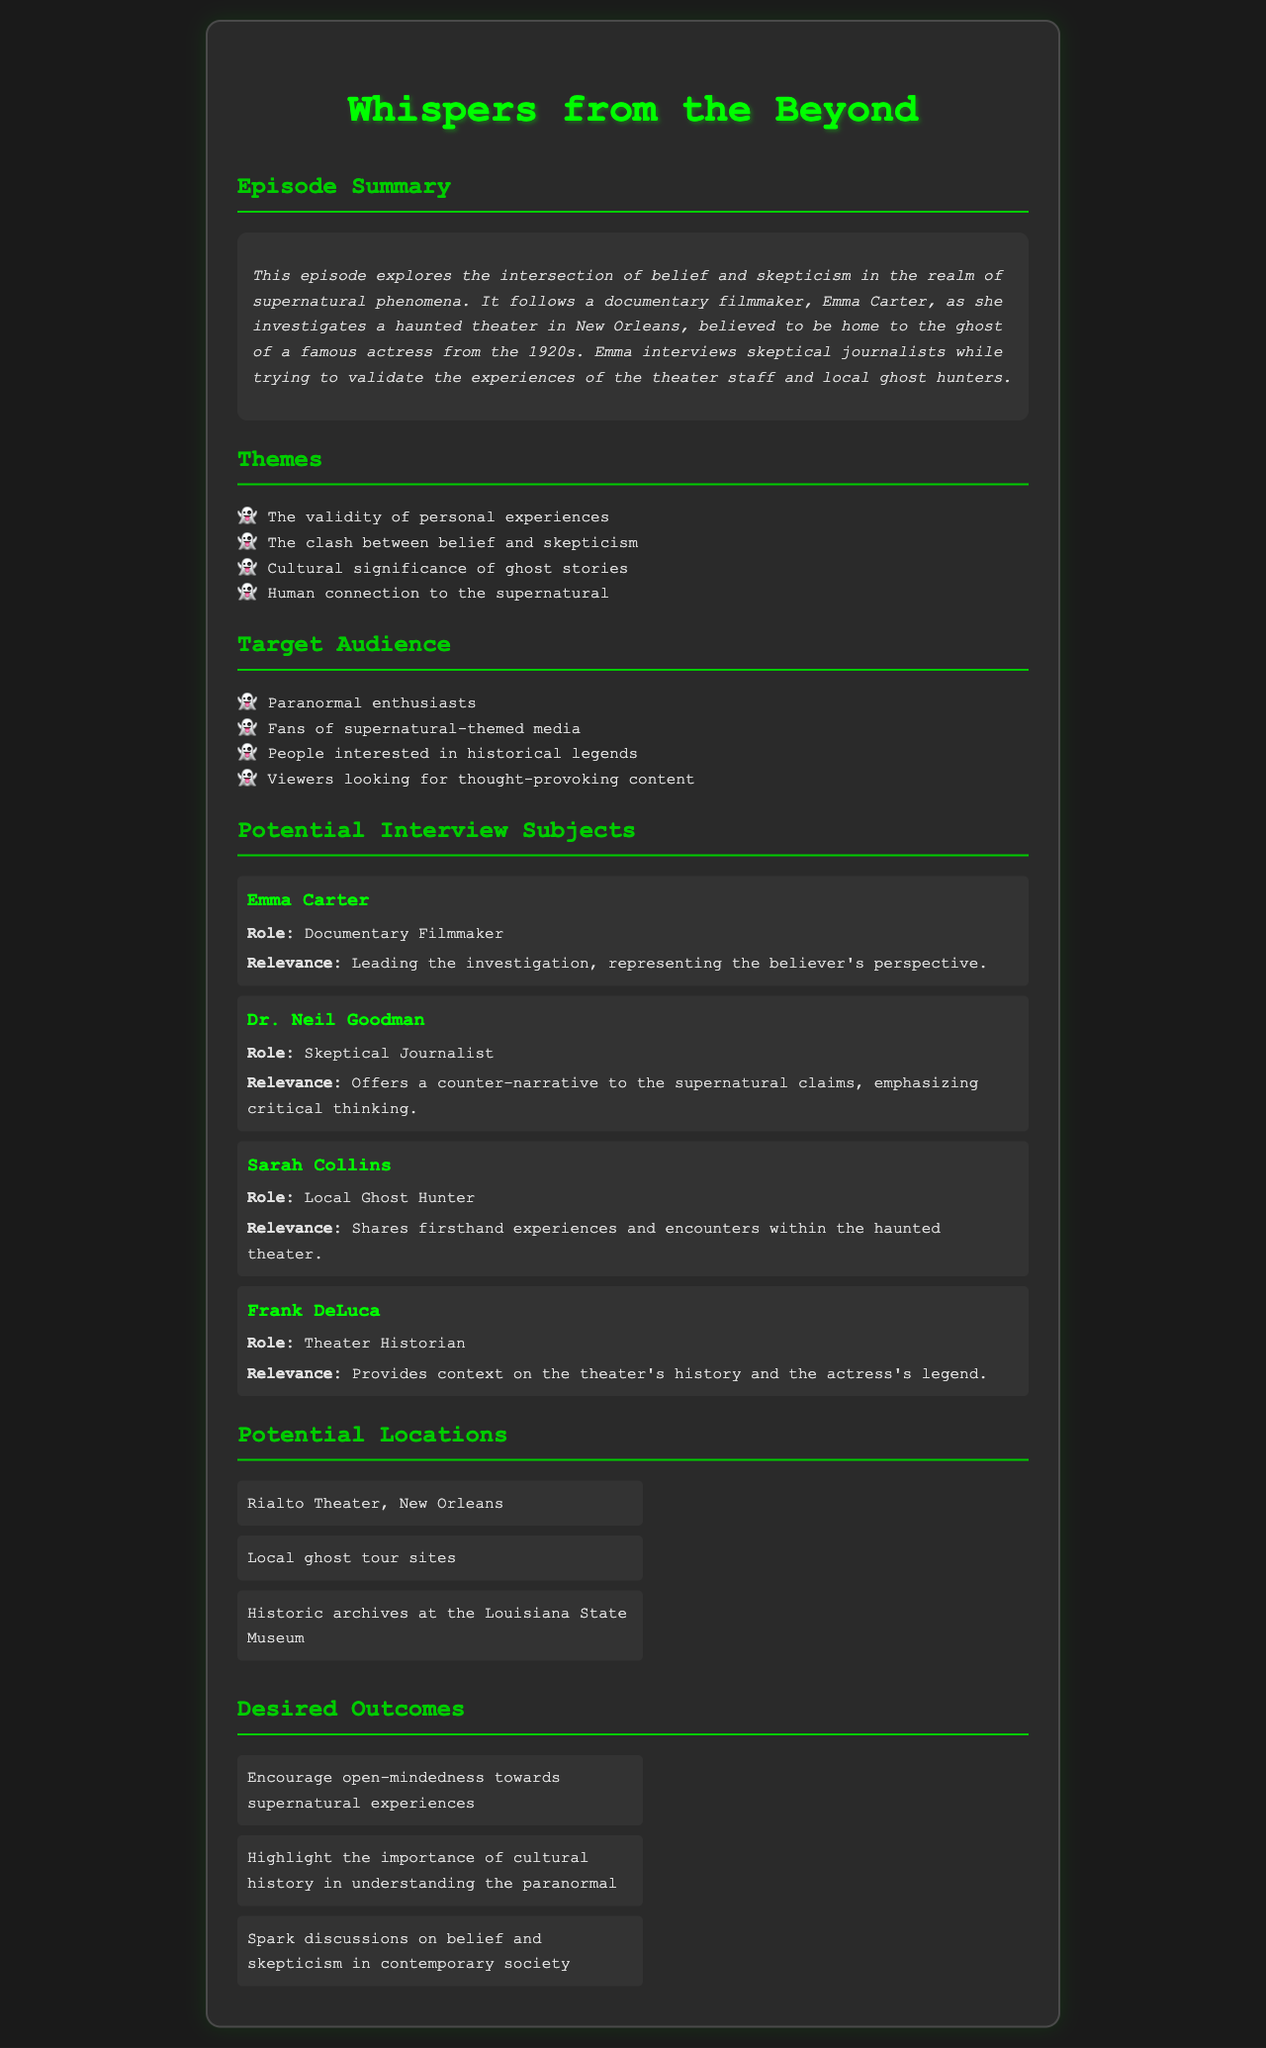What is the title of the episode? The title of the episode is stated in the document's header as "Whispers from the Beyond."
Answer: Whispers from the Beyond Who is the documentary filmmaker leading the investigation? The document identifies Emma Carter as the documentary filmmaker leading the investigation.
Answer: Emma Carter What year is the famous actress from? The summary mentions that the actress is from the 1920s.
Answer: 1920s What is one of the themes explored in this episode? The themes section lists several ideas, including "the clash between belief and skepticism."
Answer: The clash between belief and skepticism Who provides a counter-narrative to the supernatural claims? The document specifies that Dr. Neil Goodman, a skeptical journalist, offers the counter-narrative.
Answer: Dr. Neil Goodman Where is the haunted theater located? The document specifies that the haunted theater is located in New Orleans.
Answer: New Orleans What is one desired outcome of the episode? The outcomes section lists several desired impacts, such as "encourage open-mindedness towards supernatural experiences."
Answer: Encourage open-mindedness towards supernatural experiences How many potential locations are listed? The document lists three potential locations for the episode.
Answer: Three Which subject is described as sharing firsthand experiences? The document identifies Sarah Collins as the subject who shares firsthand experiences and encounters.
Answer: Sarah Collins 